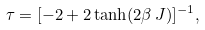<formula> <loc_0><loc_0><loc_500><loc_500>\tau = [ - 2 + 2 \tanh ( 2 \beta \, J ) ] ^ { - 1 } ,</formula> 